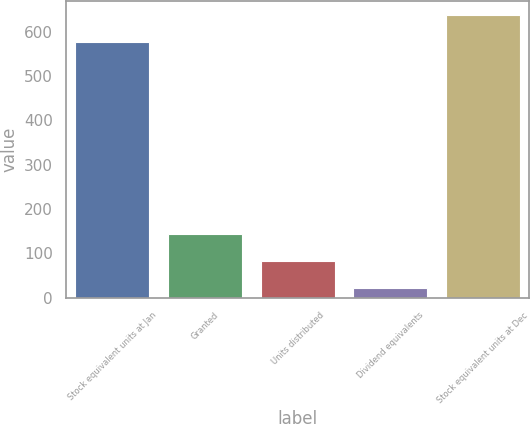Convert chart. <chart><loc_0><loc_0><loc_500><loc_500><bar_chart><fcel>Stock equivalent units at Jan<fcel>Granted<fcel>Units distributed<fcel>Dividend equivalents<fcel>Stock equivalent units at Dec<nl><fcel>577<fcel>144.8<fcel>83.4<fcel>22<fcel>638.4<nl></chart> 